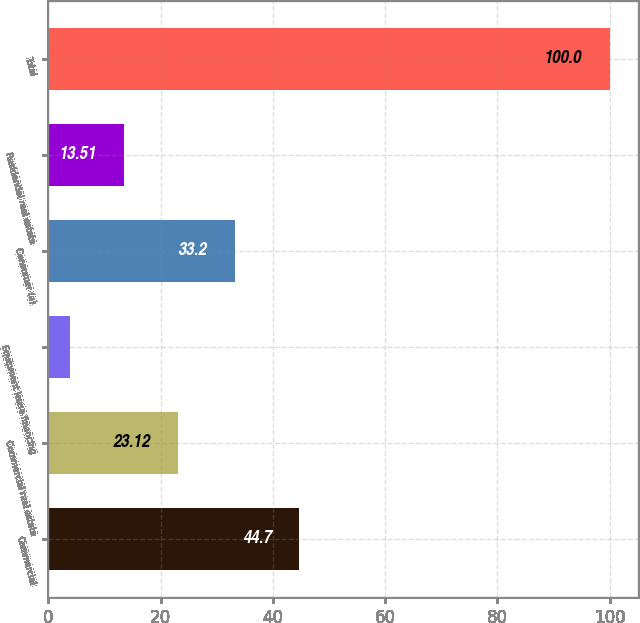Convert chart to OTSL. <chart><loc_0><loc_0><loc_500><loc_500><bar_chart><fcel>Commercial<fcel>Commercial real estate<fcel>Equipment lease financing<fcel>Consumer (a)<fcel>Residential real estate<fcel>Total<nl><fcel>44.7<fcel>23.12<fcel>3.9<fcel>33.2<fcel>13.51<fcel>100<nl></chart> 